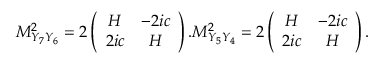<formula> <loc_0><loc_0><loc_500><loc_500>M _ { Y _ { 7 } Y _ { 6 } } ^ { 2 } = 2 \left ( \begin{array} { c c } { H } & { - 2 i c } \\ { 2 i c } & { H } \end{array} \right ) . M _ { Y _ { 5 } Y _ { 4 } } ^ { 2 } = 2 \left ( \begin{array} { c c } { H } & { - 2 i c } \\ { 2 i c } & { H } \end{array} \right ) .</formula> 